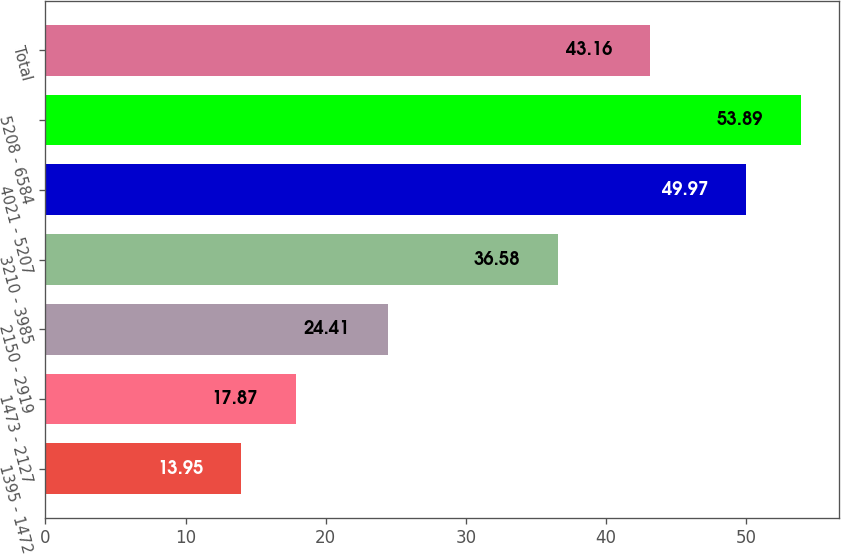Convert chart to OTSL. <chart><loc_0><loc_0><loc_500><loc_500><bar_chart><fcel>1395 - 1472<fcel>1473 - 2127<fcel>2150 - 2919<fcel>3210 - 3985<fcel>4021 - 5207<fcel>5208 - 6584<fcel>Total<nl><fcel>13.95<fcel>17.87<fcel>24.41<fcel>36.58<fcel>49.97<fcel>53.89<fcel>43.16<nl></chart> 